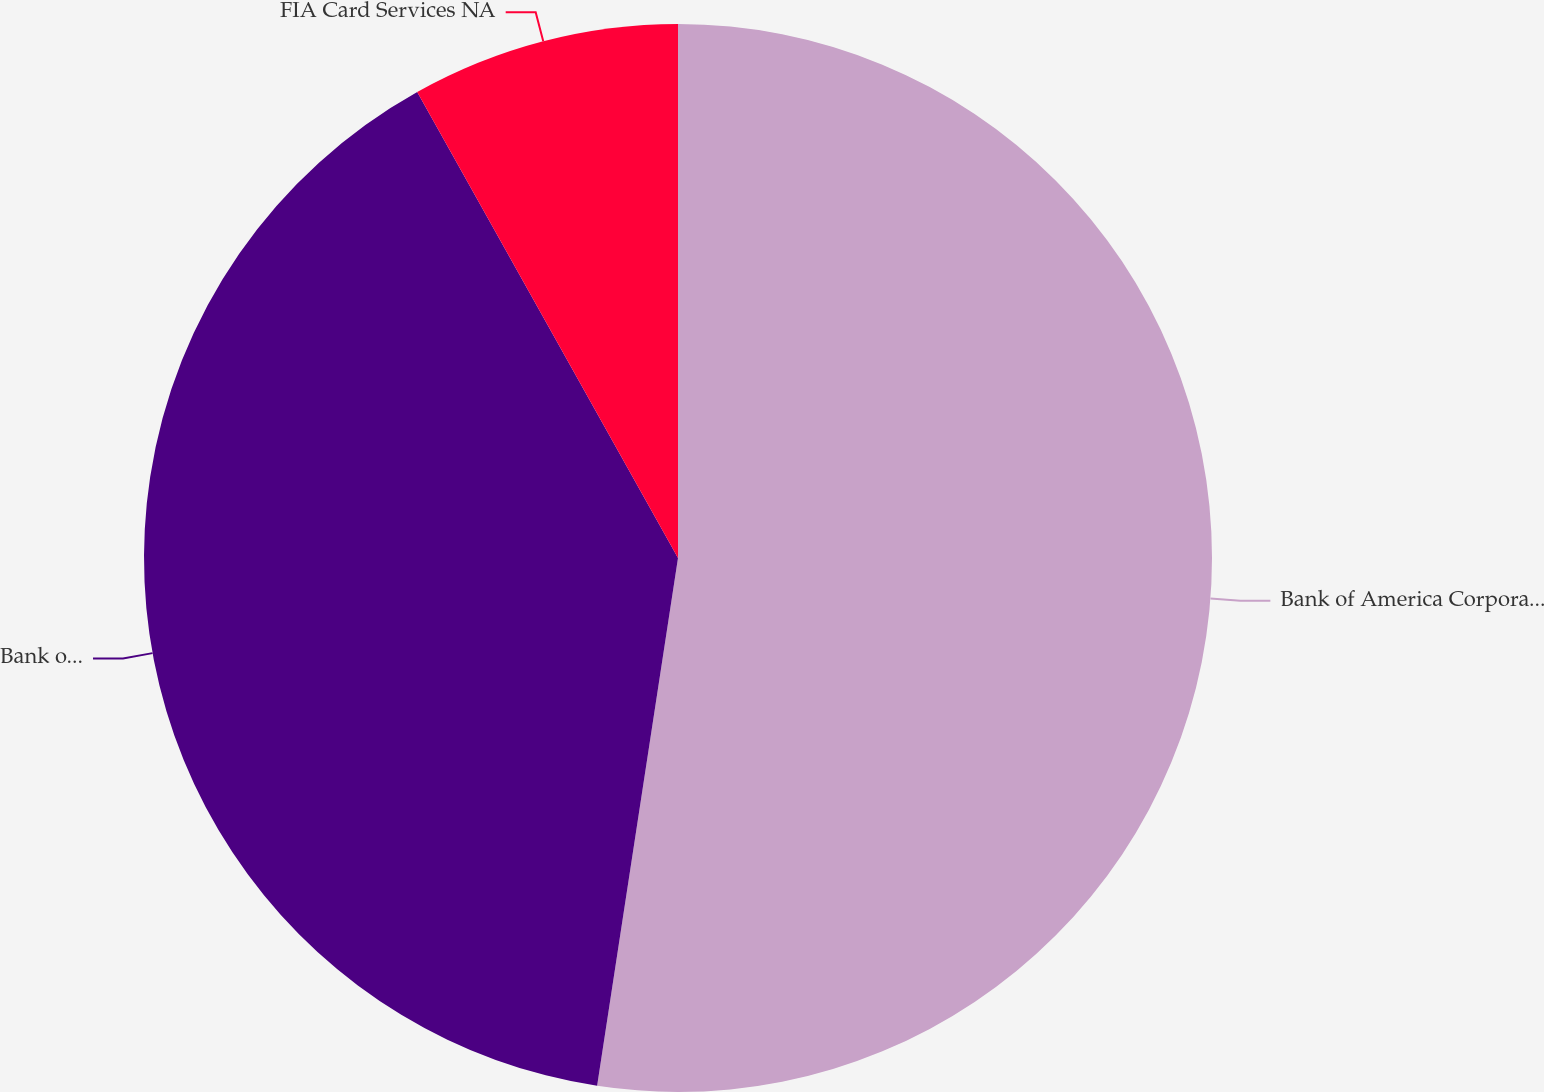<chart> <loc_0><loc_0><loc_500><loc_500><pie_chart><fcel>Bank of America Corporation<fcel>Bank of America NA<fcel>FIA Card Services NA<nl><fcel>52.42%<fcel>39.46%<fcel>8.12%<nl></chart> 